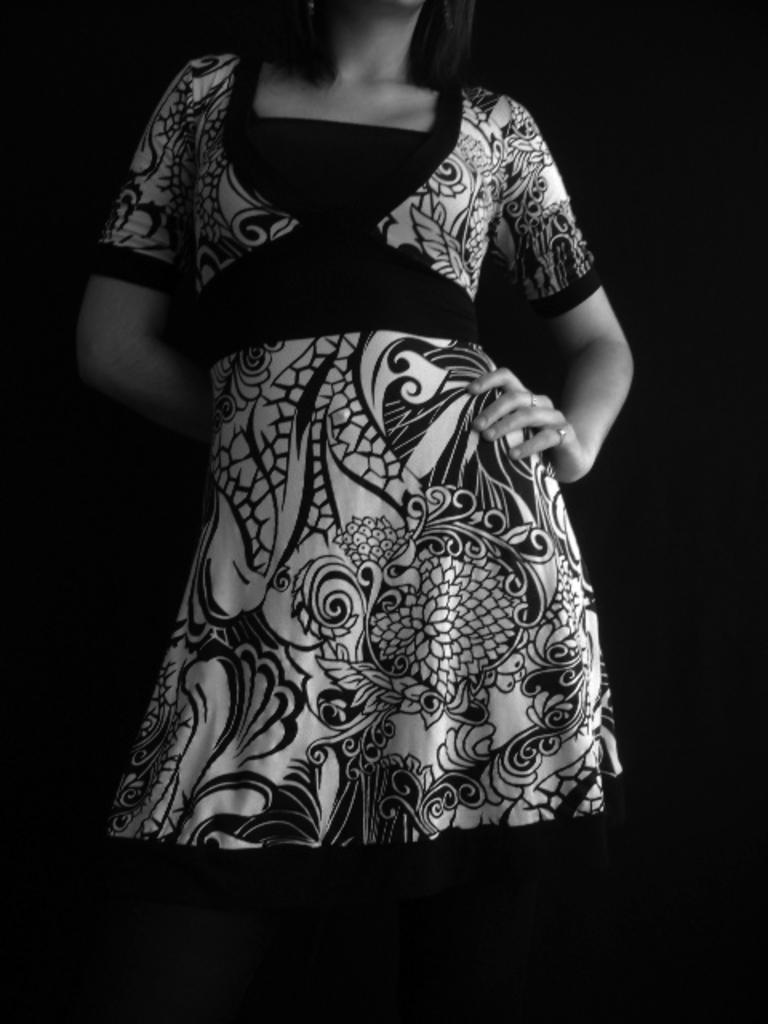Who is the main subject in the image? There is a woman in the image. How is the woman depicted in the image? The woman is truncated in the image. What can be observed about the background of the image? The background of the image is dark. What type of advertisement is the woman promoting in the image? There is no advertisement present in the image; it only features a woman who is truncated. What type of shop might the woman be working in based on her appearance in the image? There is no shop depicted in the image, and her appearance does not suggest any specific occupation or setting. 